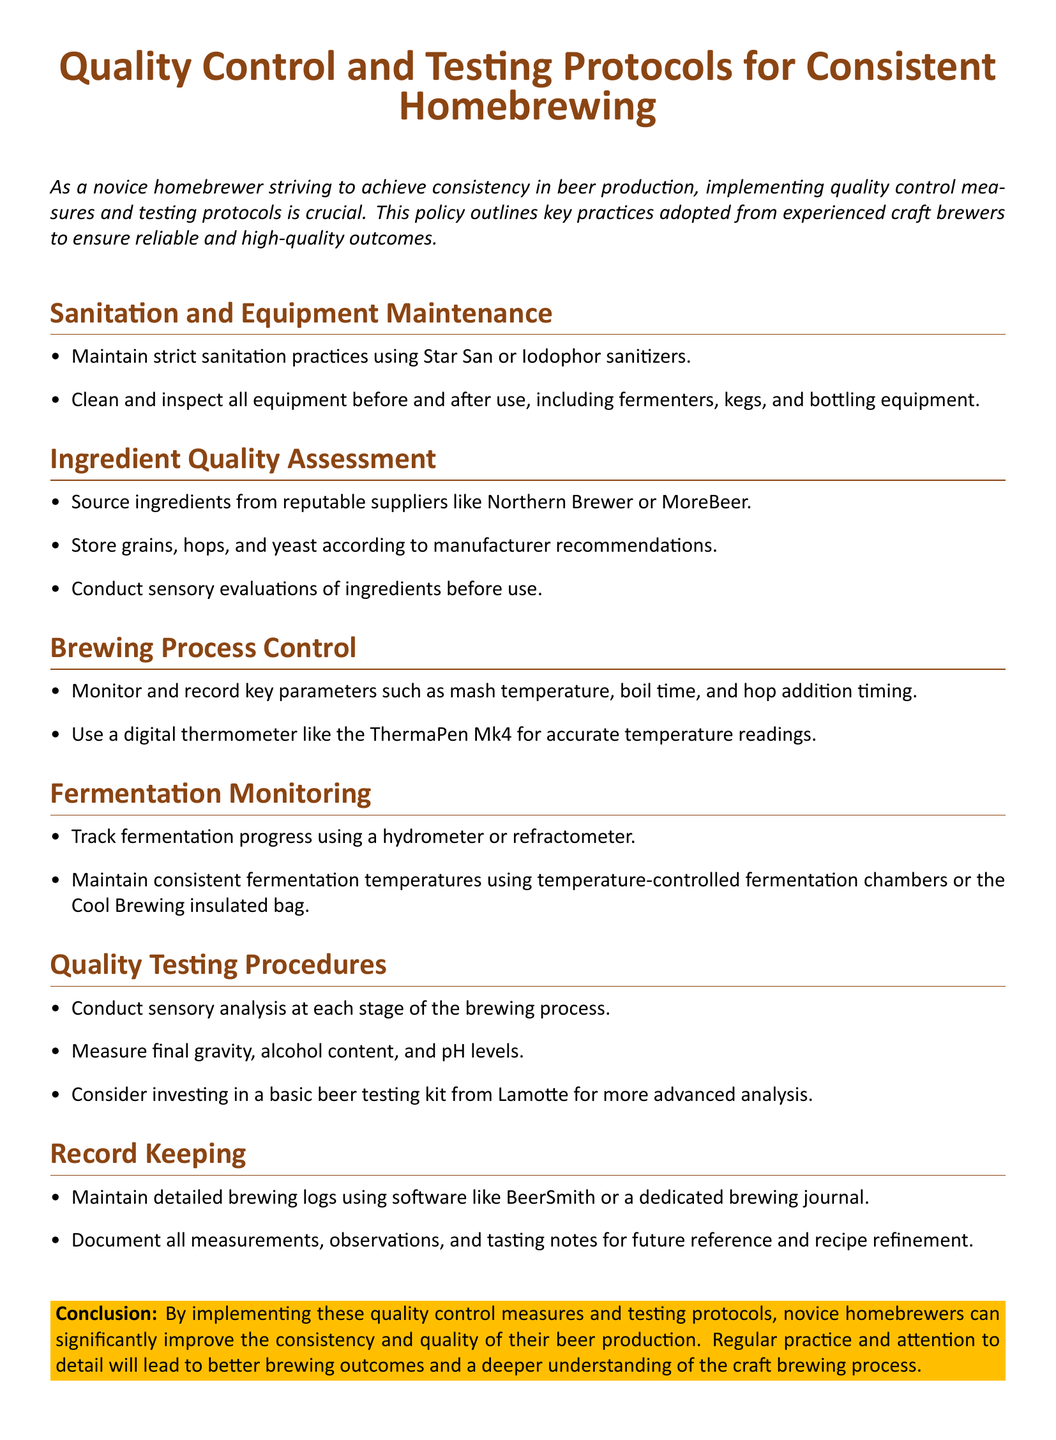What are the two sanitizers mentioned? The document lists Star San and Iodophor as the sanitizers used for sanitation practices.
Answer: Star San, Iodophor What should be used to measure fermentation progress? The document suggests using a hydrometer or refractometer to track fermentation progress.
Answer: hydrometer, refractometer What is recommended for accurate temperature readings? A digital thermometer, specifically the ThermaPen Mk4, is recommended for accurate temperature readings.
Answer: ThermaPen Mk4 Which brewing software is mentioned for record keeping? The document points out BeerSmith as a software option for maintaining detailed brewing logs.
Answer: BeerSmith How should ingredients be stored? Ingredients should be stored according to manufacturer recommendations for quality assessment.
Answer: manufacturer recommendations What is a suggested tool for sensory analysis? The document recommends conducting sensory analysis at each stage of the brewing process.
Answer: sensory analysis What is the purpose of maintaining detailed brewing logs? The purpose is to document all measurements, observations, and tasting notes for future reference and recipe refinement.
Answer: future reference and recipe refinement Which suppliers are recommended for sourcing ingredients? It is recommended to source ingredients from reputable suppliers like Northern Brewer or MoreBeer.
Answer: Northern Brewer, MoreBeer What type of analysis might a homebrewer consider investing in? The document suggests that homebrewers might consider investing in a basic beer testing kit from Lamotte for more advanced analysis.
Answer: basic beer testing kit from Lamotte 